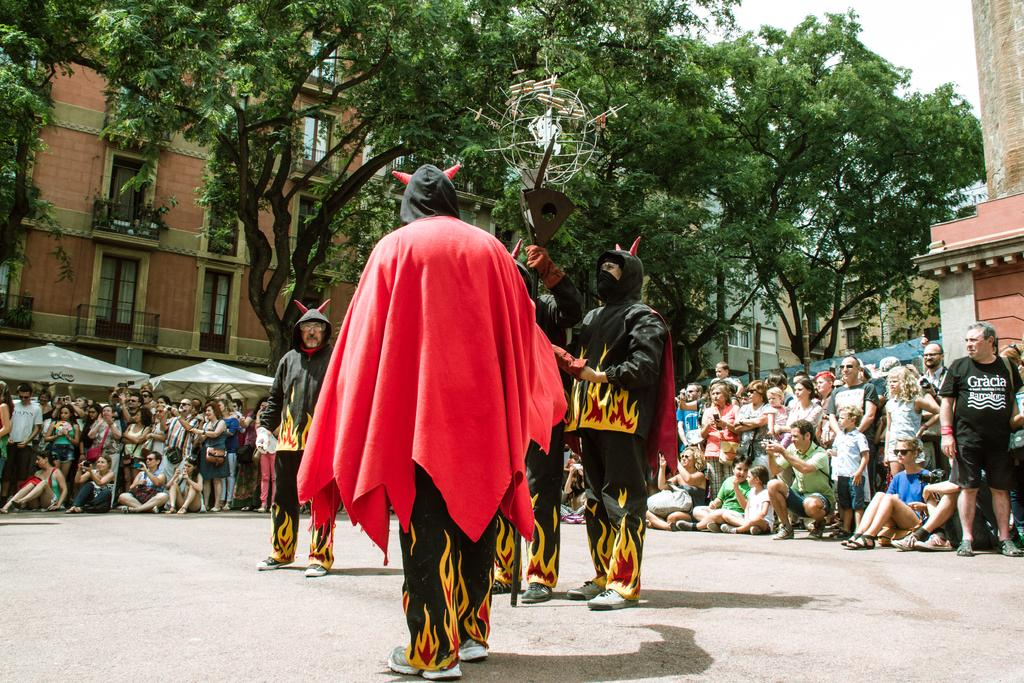What is happening on the road in the image? There are people performing a magic show on the road. Are there any spectators in the image? Yes, there are people watching the magic show. What can be seen in the background of the image? There are buildings and trees visible in the background. How many spiders are crawling on the magician's body during the performance? There are no spiders present in the image, and the magician's body is not mentioned in the provided facts. 